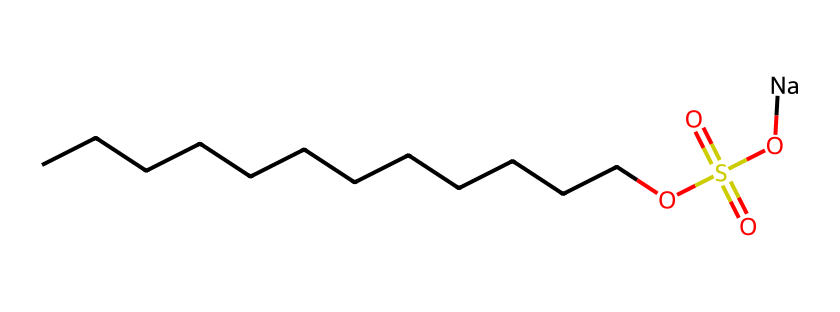What is the molecular formula of sodium lauryl sulfate? To determine the molecular formula, count the number of carbon (C), hydrogen (H), oxygen (O), and sodium (Na) atoms present in the SMILES representation. There are 12 carbon atoms, 25 hydrogen atoms, 4 oxygen atoms, and 1 sodium atom. Thus, the molecular formula is C12H25O4SNa.
Answer: C12H25O4SNa How many carbon atoms are in sodium lauryl sulfate? In the SMILES structure, count the number of contiguous 'C's present. There are 12 'C's indicating that there are 12 carbon atoms.
Answer: 12 What role does sodium play in sodium lauryl sulfate? Sodium, represented by 'Na', provides the ionic character to the molecule, allowing it to function as a surfactant by increasing the solubility of the compound in water.
Answer: ionic character How many double bonds are present in sodium lauryl sulfate? Review the SMILES representation for any double bonds, represented by '='. In the structure, there are two double bonds connected to the sulfur atom in the sulfate group, making a total of two double bonds.
Answer: 2 What is the significance of the sulfate group in sodium lauryl sulfate? The sulfate group, identified by the OS(=O)(=O) part in the SMILES, contributes to the surfactant properties of sodium lauryl sulfate, allowing it to effectively reduce surface tension in water, which helps in cleaning.
Answer: surfactant properties Why is sodium lauryl sulfate considered a surfactant? The combination of a long hydrophobic hydrocarbon chain (the lauryl part) and a hydrophilic sulfate group allows sodium lauryl sulfate to interact with both water and oils, making it effective for cleaning.
Answer: hydrophilic and hydrophobic interaction 